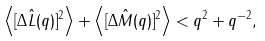<formula> <loc_0><loc_0><loc_500><loc_500>\left \langle [ \Delta \hat { L } ( q ) ] ^ { 2 } \right \rangle + \left \langle [ \Delta \hat { M } ( q ) ] ^ { 2 } \right \rangle < q ^ { 2 } + q ^ { - 2 } ,</formula> 